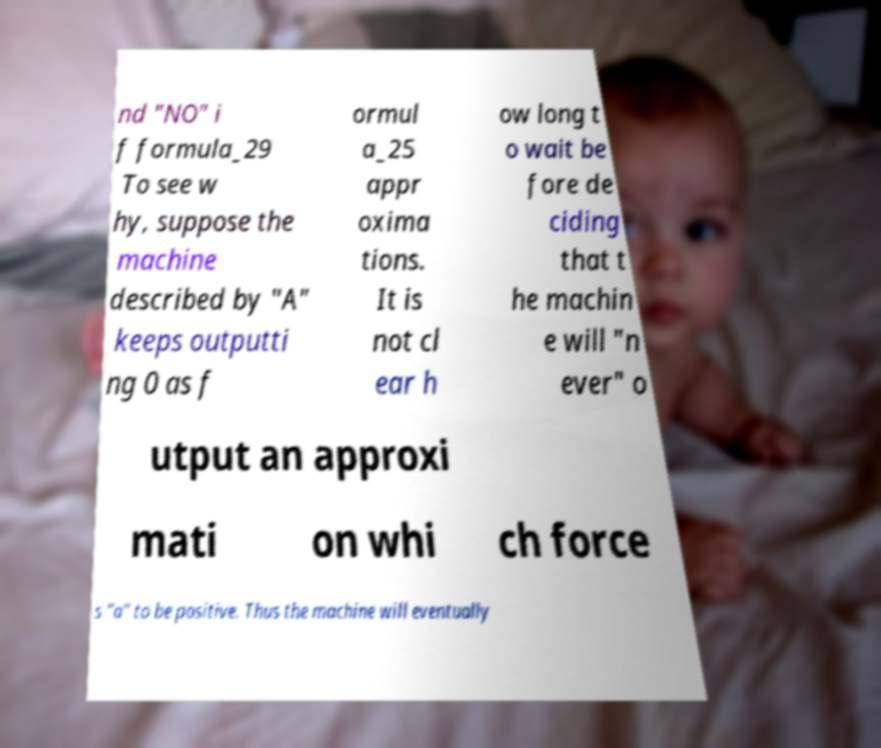Could you extract and type out the text from this image? nd "NO" i f formula_29 To see w hy, suppose the machine described by "A" keeps outputti ng 0 as f ormul a_25 appr oxima tions. It is not cl ear h ow long t o wait be fore de ciding that t he machin e will "n ever" o utput an approxi mati on whi ch force s "a" to be positive. Thus the machine will eventually 